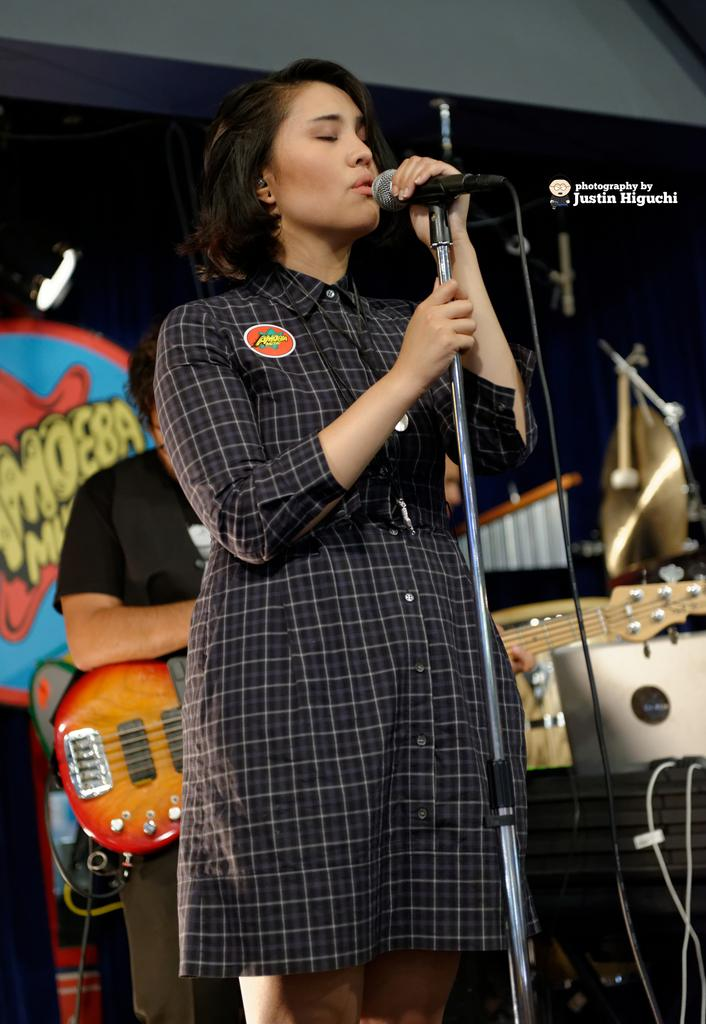What is the woman in the image doing? The woman is singing on a mic. Can you describe the man's position in the image? The man is sitting. What object is the man holding in the image? The man is holding a guitar. What type of metal can be seen in the image? There is no metal present in the image. Is there any poison visible in the image? There is no poison present in the image. How many horses are visible in the image? There are no horses present in the image. 